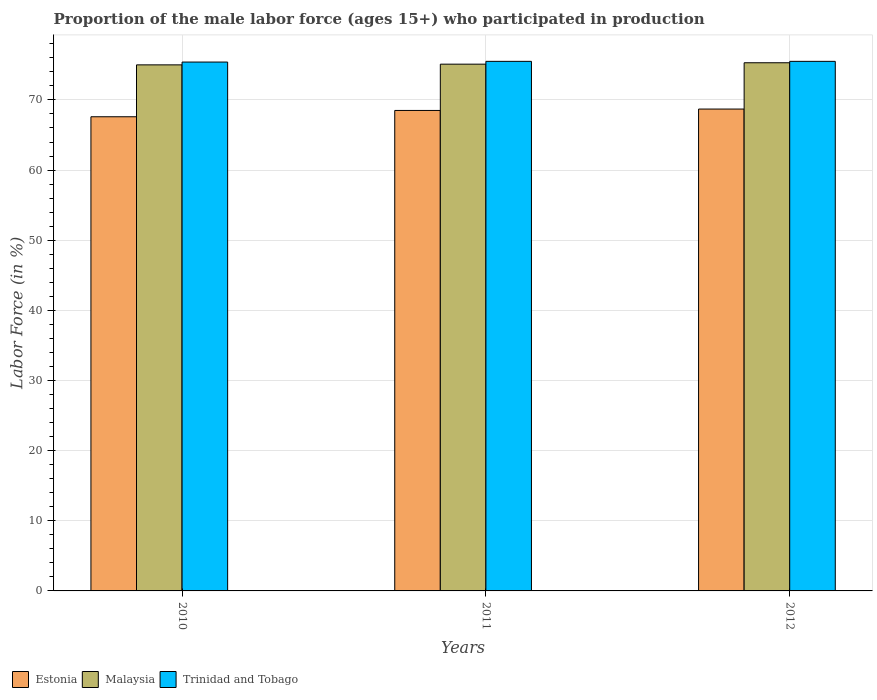How many groups of bars are there?
Offer a terse response. 3. Are the number of bars per tick equal to the number of legend labels?
Make the answer very short. Yes. Are the number of bars on each tick of the X-axis equal?
Your answer should be very brief. Yes. How many bars are there on the 2nd tick from the left?
Offer a terse response. 3. In how many cases, is the number of bars for a given year not equal to the number of legend labels?
Keep it short and to the point. 0. What is the proportion of the male labor force who participated in production in Malaysia in 2010?
Offer a terse response. 75. Across all years, what is the maximum proportion of the male labor force who participated in production in Trinidad and Tobago?
Keep it short and to the point. 75.5. Across all years, what is the minimum proportion of the male labor force who participated in production in Trinidad and Tobago?
Ensure brevity in your answer.  75.4. In which year was the proportion of the male labor force who participated in production in Estonia minimum?
Make the answer very short. 2010. What is the total proportion of the male labor force who participated in production in Malaysia in the graph?
Ensure brevity in your answer.  225.4. What is the difference between the proportion of the male labor force who participated in production in Trinidad and Tobago in 2010 and that in 2012?
Your answer should be compact. -0.1. What is the difference between the proportion of the male labor force who participated in production in Trinidad and Tobago in 2011 and the proportion of the male labor force who participated in production in Estonia in 2010?
Give a very brief answer. 7.9. What is the average proportion of the male labor force who participated in production in Trinidad and Tobago per year?
Provide a succinct answer. 75.47. In the year 2011, what is the difference between the proportion of the male labor force who participated in production in Malaysia and proportion of the male labor force who participated in production in Estonia?
Your answer should be very brief. 6.6. What is the ratio of the proportion of the male labor force who participated in production in Malaysia in 2010 to that in 2012?
Keep it short and to the point. 1. Is the proportion of the male labor force who participated in production in Malaysia in 2011 less than that in 2012?
Your response must be concise. Yes. Is the difference between the proportion of the male labor force who participated in production in Malaysia in 2010 and 2012 greater than the difference between the proportion of the male labor force who participated in production in Estonia in 2010 and 2012?
Make the answer very short. Yes. What is the difference between the highest and the lowest proportion of the male labor force who participated in production in Malaysia?
Your answer should be compact. 0.3. In how many years, is the proportion of the male labor force who participated in production in Estonia greater than the average proportion of the male labor force who participated in production in Estonia taken over all years?
Give a very brief answer. 2. What does the 1st bar from the left in 2010 represents?
Offer a terse response. Estonia. What does the 2nd bar from the right in 2010 represents?
Provide a succinct answer. Malaysia. How many bars are there?
Provide a short and direct response. 9. Are all the bars in the graph horizontal?
Provide a short and direct response. No. What is the difference between two consecutive major ticks on the Y-axis?
Make the answer very short. 10. Where does the legend appear in the graph?
Keep it short and to the point. Bottom left. What is the title of the graph?
Provide a short and direct response. Proportion of the male labor force (ages 15+) who participated in production. Does "Maldives" appear as one of the legend labels in the graph?
Keep it short and to the point. No. What is the label or title of the X-axis?
Your answer should be compact. Years. What is the label or title of the Y-axis?
Offer a terse response. Labor Force (in %). What is the Labor Force (in %) in Estonia in 2010?
Ensure brevity in your answer.  67.6. What is the Labor Force (in %) of Malaysia in 2010?
Offer a terse response. 75. What is the Labor Force (in %) of Trinidad and Tobago in 2010?
Give a very brief answer. 75.4. What is the Labor Force (in %) of Estonia in 2011?
Provide a succinct answer. 68.5. What is the Labor Force (in %) in Malaysia in 2011?
Provide a short and direct response. 75.1. What is the Labor Force (in %) of Trinidad and Tobago in 2011?
Ensure brevity in your answer.  75.5. What is the Labor Force (in %) of Estonia in 2012?
Ensure brevity in your answer.  68.7. What is the Labor Force (in %) in Malaysia in 2012?
Provide a short and direct response. 75.3. What is the Labor Force (in %) in Trinidad and Tobago in 2012?
Provide a short and direct response. 75.5. Across all years, what is the maximum Labor Force (in %) of Estonia?
Your answer should be compact. 68.7. Across all years, what is the maximum Labor Force (in %) in Malaysia?
Provide a succinct answer. 75.3. Across all years, what is the maximum Labor Force (in %) of Trinidad and Tobago?
Offer a very short reply. 75.5. Across all years, what is the minimum Labor Force (in %) in Estonia?
Ensure brevity in your answer.  67.6. Across all years, what is the minimum Labor Force (in %) in Malaysia?
Give a very brief answer. 75. Across all years, what is the minimum Labor Force (in %) of Trinidad and Tobago?
Offer a terse response. 75.4. What is the total Labor Force (in %) in Estonia in the graph?
Your response must be concise. 204.8. What is the total Labor Force (in %) of Malaysia in the graph?
Your response must be concise. 225.4. What is the total Labor Force (in %) of Trinidad and Tobago in the graph?
Provide a short and direct response. 226.4. What is the difference between the Labor Force (in %) of Trinidad and Tobago in 2010 and that in 2011?
Your answer should be compact. -0.1. What is the difference between the Labor Force (in %) in Estonia in 2010 and that in 2012?
Offer a terse response. -1.1. What is the difference between the Labor Force (in %) of Malaysia in 2010 and that in 2012?
Your answer should be very brief. -0.3. What is the difference between the Labor Force (in %) of Estonia in 2011 and that in 2012?
Give a very brief answer. -0.2. What is the difference between the Labor Force (in %) in Trinidad and Tobago in 2011 and that in 2012?
Your answer should be very brief. 0. What is the difference between the Labor Force (in %) of Estonia in 2010 and the Labor Force (in %) of Trinidad and Tobago in 2011?
Provide a succinct answer. -7.9. What is the difference between the Labor Force (in %) of Malaysia in 2010 and the Labor Force (in %) of Trinidad and Tobago in 2011?
Offer a terse response. -0.5. What is the difference between the Labor Force (in %) in Estonia in 2011 and the Labor Force (in %) in Malaysia in 2012?
Your response must be concise. -6.8. What is the difference between the Labor Force (in %) in Malaysia in 2011 and the Labor Force (in %) in Trinidad and Tobago in 2012?
Ensure brevity in your answer.  -0.4. What is the average Labor Force (in %) of Estonia per year?
Your answer should be compact. 68.27. What is the average Labor Force (in %) in Malaysia per year?
Your answer should be compact. 75.13. What is the average Labor Force (in %) in Trinidad and Tobago per year?
Your answer should be compact. 75.47. In the year 2010, what is the difference between the Labor Force (in %) of Estonia and Labor Force (in %) of Malaysia?
Your answer should be compact. -7.4. In the year 2010, what is the difference between the Labor Force (in %) in Malaysia and Labor Force (in %) in Trinidad and Tobago?
Offer a very short reply. -0.4. In the year 2011, what is the difference between the Labor Force (in %) in Malaysia and Labor Force (in %) in Trinidad and Tobago?
Offer a terse response. -0.4. In the year 2012, what is the difference between the Labor Force (in %) in Estonia and Labor Force (in %) in Malaysia?
Give a very brief answer. -6.6. In the year 2012, what is the difference between the Labor Force (in %) of Estonia and Labor Force (in %) of Trinidad and Tobago?
Your response must be concise. -6.8. What is the ratio of the Labor Force (in %) of Estonia in 2010 to that in 2011?
Provide a short and direct response. 0.99. What is the ratio of the Labor Force (in %) of Trinidad and Tobago in 2010 to that in 2011?
Your answer should be very brief. 1. What is the ratio of the Labor Force (in %) in Estonia in 2010 to that in 2012?
Ensure brevity in your answer.  0.98. What is the ratio of the Labor Force (in %) in Malaysia in 2010 to that in 2012?
Provide a succinct answer. 1. What is the ratio of the Labor Force (in %) in Trinidad and Tobago in 2010 to that in 2012?
Provide a short and direct response. 1. What is the difference between the highest and the second highest Labor Force (in %) in Estonia?
Offer a very short reply. 0.2. What is the difference between the highest and the second highest Labor Force (in %) in Malaysia?
Give a very brief answer. 0.2. 